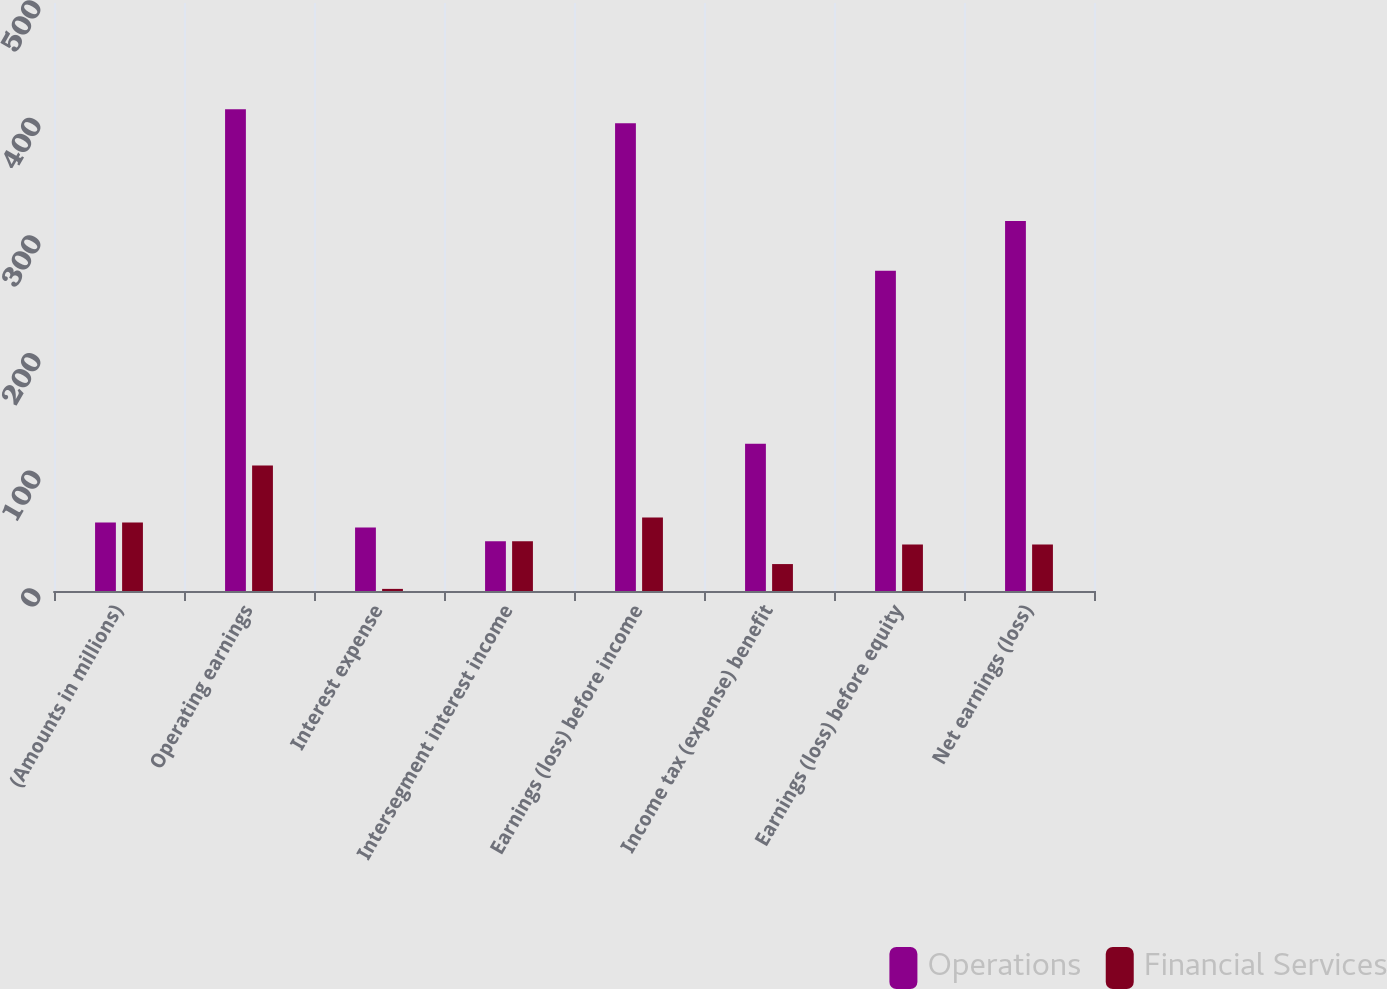<chart> <loc_0><loc_0><loc_500><loc_500><stacked_bar_chart><ecel><fcel>(Amounts in millions)<fcel>Operating earnings<fcel>Interest expense<fcel>Intersegment interest income<fcel>Earnings (loss) before income<fcel>Income tax (expense) benefit<fcel>Earnings (loss) before equity<fcel>Net earnings (loss)<nl><fcel>Operations<fcel>58.25<fcel>409.7<fcel>54<fcel>42.4<fcel>397.7<fcel>125.3<fcel>272.4<fcel>314.6<nl><fcel>Financial Services<fcel>58.25<fcel>106.7<fcel>1.8<fcel>42.4<fcel>62.5<fcel>22.9<fcel>39.6<fcel>39.6<nl></chart> 